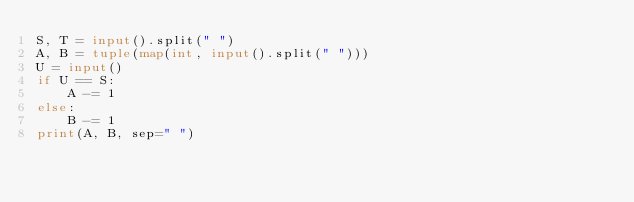<code> <loc_0><loc_0><loc_500><loc_500><_Python_>S, T = input().split(" ")
A, B = tuple(map(int, input().split(" ")))
U = input()
if U == S:
    A -= 1
else:
    B -= 1
print(A, B, sep=" ")</code> 